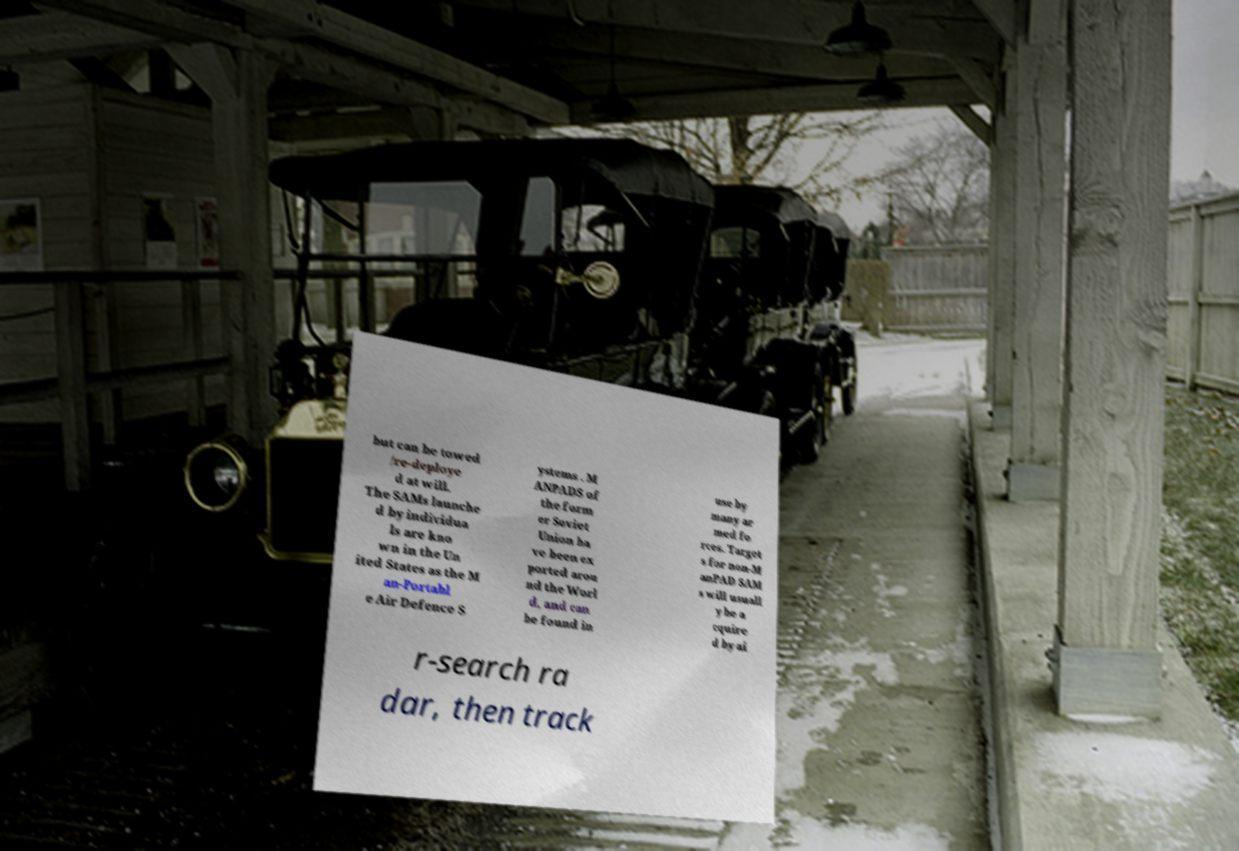What messages or text are displayed in this image? I need them in a readable, typed format. but can be towed /re-deploye d at will. The SAMs launche d by individua ls are kno wn in the Un ited States as the M an-Portabl e Air Defence S ystems . M ANPADS of the form er Soviet Union ha ve been ex ported arou nd the Worl d, and can be found in use by many ar med fo rces. Target s for non-M anPAD SAM s will usuall y be a cquire d by ai r-search ra dar, then track 